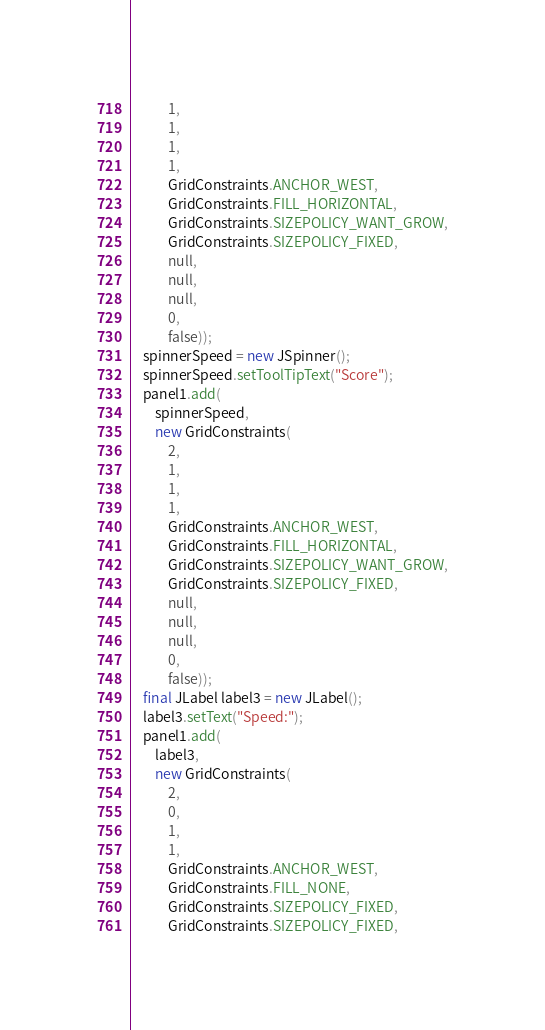Convert code to text. <code><loc_0><loc_0><loc_500><loc_500><_Java_>            1,
            1,
            1,
            1,
            GridConstraints.ANCHOR_WEST,
            GridConstraints.FILL_HORIZONTAL,
            GridConstraints.SIZEPOLICY_WANT_GROW,
            GridConstraints.SIZEPOLICY_FIXED,
            null,
            null,
            null,
            0,
            false));
    spinnerSpeed = new JSpinner();
    spinnerSpeed.setToolTipText("Score");
    panel1.add(
        spinnerSpeed,
        new GridConstraints(
            2,
            1,
            1,
            1,
            GridConstraints.ANCHOR_WEST,
            GridConstraints.FILL_HORIZONTAL,
            GridConstraints.SIZEPOLICY_WANT_GROW,
            GridConstraints.SIZEPOLICY_FIXED,
            null,
            null,
            null,
            0,
            false));
    final JLabel label3 = new JLabel();
    label3.setText("Speed:");
    panel1.add(
        label3,
        new GridConstraints(
            2,
            0,
            1,
            1,
            GridConstraints.ANCHOR_WEST,
            GridConstraints.FILL_NONE,
            GridConstraints.SIZEPOLICY_FIXED,
            GridConstraints.SIZEPOLICY_FIXED,</code> 